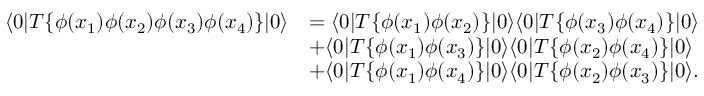<formula> <loc_0><loc_0><loc_500><loc_500>{ \begin{array} { r l } { \langle 0 | T \{ \phi ( x _ { 1 } ) \phi ( x _ { 2 } ) \phi ( x _ { 3 } ) \phi ( x _ { 4 } ) \} | 0 \rangle } & { = \langle 0 | T \{ \phi ( x _ { 1 } ) \phi ( x _ { 2 } ) \} | 0 \rangle \langle 0 | T \{ \phi ( x _ { 3 } ) \phi ( x _ { 4 } ) \} | 0 \rangle } \\ & { + \langle 0 | T \{ \phi ( x _ { 1 } ) \phi ( x _ { 3 } ) \} | 0 \rangle \langle 0 | T \{ \phi ( x _ { 2 } ) \phi ( x _ { 4 } ) \} | 0 \rangle } \\ & { + \langle 0 | T \{ \phi ( x _ { 1 } ) \phi ( x _ { 4 } ) \} | 0 \rangle \langle 0 | T \{ \phi ( x _ { 2 } ) \phi ( x _ { 3 } ) \} | 0 \rangle . } \end{array} }</formula> 